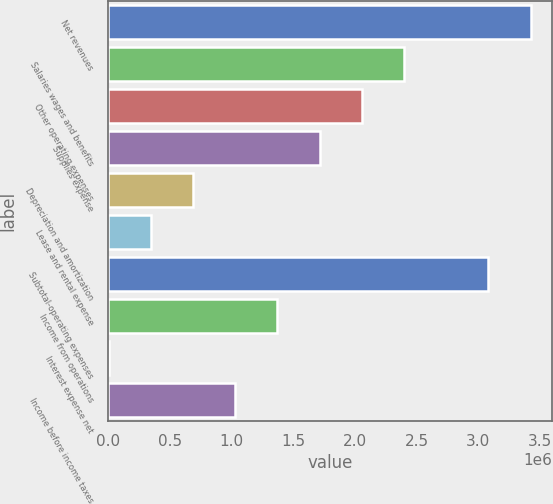Convert chart. <chart><loc_0><loc_0><loc_500><loc_500><bar_chart><fcel>Net revenues<fcel>Salaries wages and benefits<fcel>Other operating expenses<fcel>Supplies expense<fcel>Depreciation and amortization<fcel>Lease and rental expense<fcel>Subtotal-operating expenses<fcel>Income from operations<fcel>Interest expense net<fcel>Income before income taxes<nl><fcel>3.42396e+06<fcel>2.39794e+06<fcel>2.05594e+06<fcel>1.71393e+06<fcel>687914<fcel>345908<fcel>3.07729e+06<fcel>1.37192e+06<fcel>3903<fcel>1.02992e+06<nl></chart> 